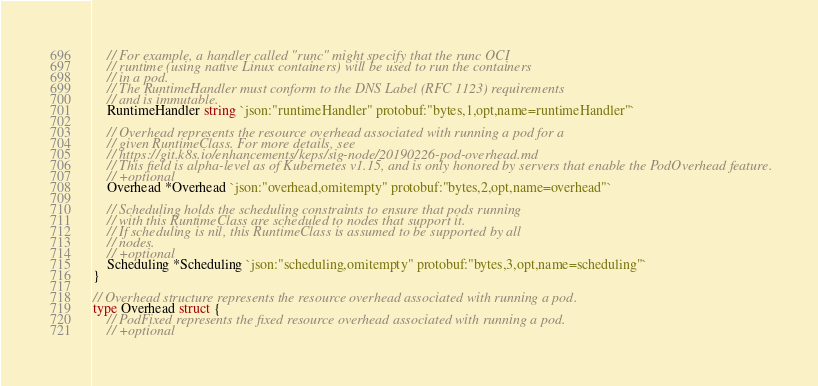<code> <loc_0><loc_0><loc_500><loc_500><_Go_>	// For example, a handler called "runc" might specify that the runc OCI
	// runtime (using native Linux containers) will be used to run the containers
	// in a pod.
	// The RuntimeHandler must conform to the DNS Label (RFC 1123) requirements
	// and is immutable.
	RuntimeHandler string `json:"runtimeHandler" protobuf:"bytes,1,opt,name=runtimeHandler"`

	// Overhead represents the resource overhead associated with running a pod for a
	// given RuntimeClass. For more details, see
	// https://git.k8s.io/enhancements/keps/sig-node/20190226-pod-overhead.md
	// This field is alpha-level as of Kubernetes v1.15, and is only honored by servers that enable the PodOverhead feature.
	// +optional
	Overhead *Overhead `json:"overhead,omitempty" protobuf:"bytes,2,opt,name=overhead"`

	// Scheduling holds the scheduling constraints to ensure that pods running
	// with this RuntimeClass are scheduled to nodes that support it.
	// If scheduling is nil, this RuntimeClass is assumed to be supported by all
	// nodes.
	// +optional
	Scheduling *Scheduling `json:"scheduling,omitempty" protobuf:"bytes,3,opt,name=scheduling"`
}

// Overhead structure represents the resource overhead associated with running a pod.
type Overhead struct {
	// PodFixed represents the fixed resource overhead associated with running a pod.
	// +optional</code> 